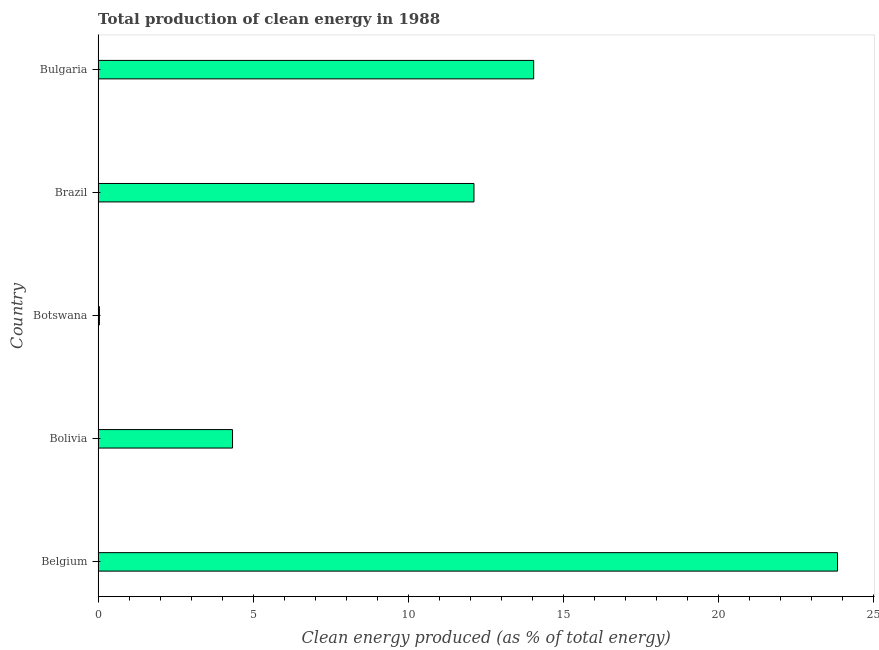Does the graph contain grids?
Ensure brevity in your answer.  No. What is the title of the graph?
Make the answer very short. Total production of clean energy in 1988. What is the label or title of the X-axis?
Keep it short and to the point. Clean energy produced (as % of total energy). What is the production of clean energy in Brazil?
Ensure brevity in your answer.  12.12. Across all countries, what is the maximum production of clean energy?
Give a very brief answer. 23.84. Across all countries, what is the minimum production of clean energy?
Your response must be concise. 0.04. In which country was the production of clean energy minimum?
Make the answer very short. Botswana. What is the sum of the production of clean energy?
Ensure brevity in your answer.  54.39. What is the difference between the production of clean energy in Belgium and Bolivia?
Keep it short and to the point. 19.51. What is the average production of clean energy per country?
Make the answer very short. 10.88. What is the median production of clean energy?
Provide a succinct answer. 12.12. What is the ratio of the production of clean energy in Botswana to that in Brazil?
Make the answer very short. 0. Is the production of clean energy in Belgium less than that in Bolivia?
Your answer should be very brief. No. Is the difference between the production of clean energy in Belgium and Brazil greater than the difference between any two countries?
Your answer should be very brief. No. What is the difference between the highest and the second highest production of clean energy?
Your response must be concise. 9.8. What is the difference between the highest and the lowest production of clean energy?
Provide a short and direct response. 23.8. In how many countries, is the production of clean energy greater than the average production of clean energy taken over all countries?
Keep it short and to the point. 3. Are all the bars in the graph horizontal?
Ensure brevity in your answer.  Yes. What is the difference between two consecutive major ticks on the X-axis?
Your answer should be compact. 5. What is the Clean energy produced (as % of total energy) in Belgium?
Make the answer very short. 23.84. What is the Clean energy produced (as % of total energy) in Bolivia?
Provide a succinct answer. 4.34. What is the Clean energy produced (as % of total energy) in Botswana?
Your answer should be very brief. 0.04. What is the Clean energy produced (as % of total energy) in Brazil?
Keep it short and to the point. 12.12. What is the Clean energy produced (as % of total energy) in Bulgaria?
Provide a short and direct response. 14.05. What is the difference between the Clean energy produced (as % of total energy) in Belgium and Bolivia?
Make the answer very short. 19.51. What is the difference between the Clean energy produced (as % of total energy) in Belgium and Botswana?
Provide a succinct answer. 23.8. What is the difference between the Clean energy produced (as % of total energy) in Belgium and Brazil?
Provide a short and direct response. 11.72. What is the difference between the Clean energy produced (as % of total energy) in Belgium and Bulgaria?
Provide a succinct answer. 9.8. What is the difference between the Clean energy produced (as % of total energy) in Bolivia and Botswana?
Offer a terse response. 4.29. What is the difference between the Clean energy produced (as % of total energy) in Bolivia and Brazil?
Provide a succinct answer. -7.79. What is the difference between the Clean energy produced (as % of total energy) in Bolivia and Bulgaria?
Make the answer very short. -9.71. What is the difference between the Clean energy produced (as % of total energy) in Botswana and Brazil?
Your answer should be very brief. -12.08. What is the difference between the Clean energy produced (as % of total energy) in Botswana and Bulgaria?
Keep it short and to the point. -14. What is the difference between the Clean energy produced (as % of total energy) in Brazil and Bulgaria?
Provide a short and direct response. -1.93. What is the ratio of the Clean energy produced (as % of total energy) in Belgium to that in Bolivia?
Your answer should be compact. 5.5. What is the ratio of the Clean energy produced (as % of total energy) in Belgium to that in Botswana?
Offer a very short reply. 550.39. What is the ratio of the Clean energy produced (as % of total energy) in Belgium to that in Brazil?
Give a very brief answer. 1.97. What is the ratio of the Clean energy produced (as % of total energy) in Belgium to that in Bulgaria?
Offer a very short reply. 1.7. What is the ratio of the Clean energy produced (as % of total energy) in Bolivia to that in Botswana?
Keep it short and to the point. 100.08. What is the ratio of the Clean energy produced (as % of total energy) in Bolivia to that in Brazil?
Your answer should be compact. 0.36. What is the ratio of the Clean energy produced (as % of total energy) in Bolivia to that in Bulgaria?
Provide a succinct answer. 0.31. What is the ratio of the Clean energy produced (as % of total energy) in Botswana to that in Brazil?
Make the answer very short. 0. What is the ratio of the Clean energy produced (as % of total energy) in Botswana to that in Bulgaria?
Your response must be concise. 0. What is the ratio of the Clean energy produced (as % of total energy) in Brazil to that in Bulgaria?
Provide a short and direct response. 0.86. 